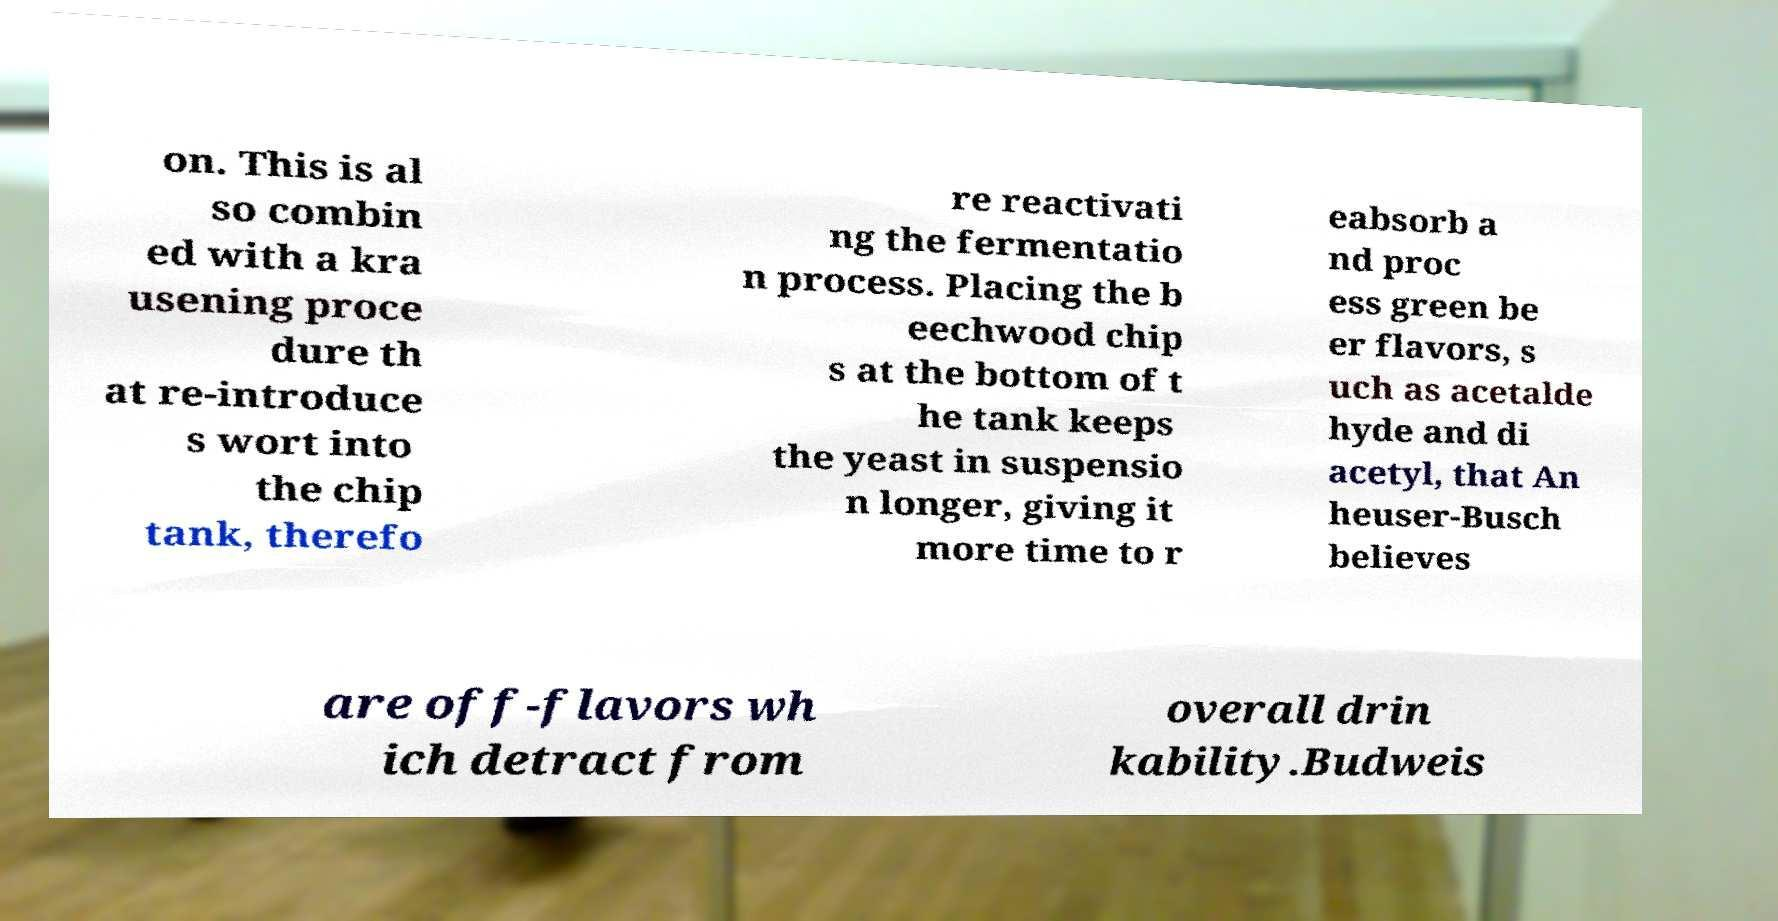There's text embedded in this image that I need extracted. Can you transcribe it verbatim? on. This is al so combin ed with a kra usening proce dure th at re-introduce s wort into the chip tank, therefo re reactivati ng the fermentatio n process. Placing the b eechwood chip s at the bottom of t he tank keeps the yeast in suspensio n longer, giving it more time to r eabsorb a nd proc ess green be er flavors, s uch as acetalde hyde and di acetyl, that An heuser-Busch believes are off-flavors wh ich detract from overall drin kability.Budweis 